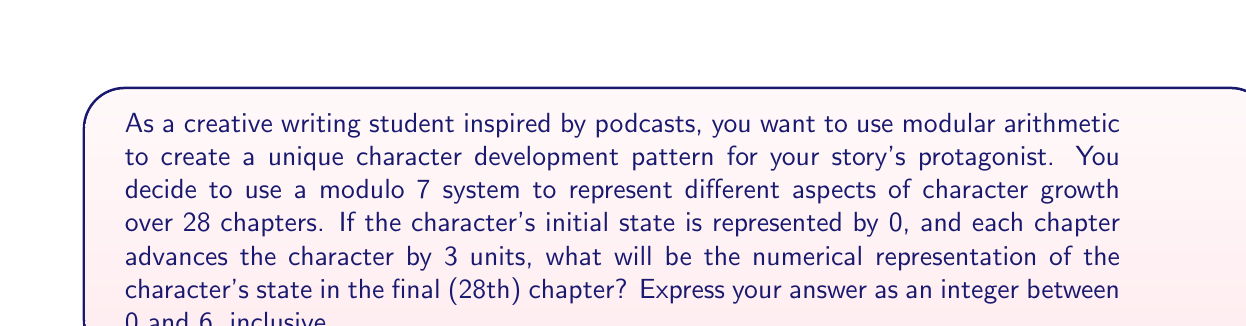Solve this math problem. Let's approach this step-by-step:

1) We're using a modulo 7 system, which means our values will always be in the range 0 to 6.

2) The character advances by 3 units each chapter. We can represent this mathematically as:

   $$(initial\_state + 3 \times number\_of\_chapters) \bmod 7$$

3) We know:
   - Initial state = 0
   - Number of chapters = 28

4) Let's plug these into our formula:

   $$(0 + 3 \times 28) \bmod 7$$

5) First, let's multiply:

   $$(0 + 84) \bmod 7$$

6) Now we have:

   $$84 \bmod 7$$

7) To solve this, we divide 84 by 7 and take the remainder:
   
   $$84 \div 7 = 12 \text{ remainder } 0$$

8) The remainder is our answer in the modulo 7 system.

This pattern creates a cyclical character development, where the character returns to their initial state (0) every 7 chapters, providing a unique structure for character growth and regression throughout the story.
Answer: 0 